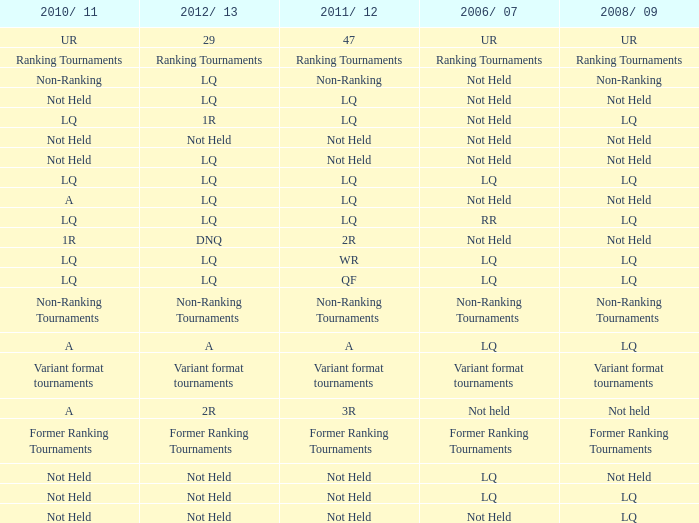Could you parse the entire table? {'header': ['2010/ 11', '2012/ 13', '2011/ 12', '2006/ 07', '2008/ 09'], 'rows': [['UR', '29', '47', 'UR', 'UR'], ['Ranking Tournaments', 'Ranking Tournaments', 'Ranking Tournaments', 'Ranking Tournaments', 'Ranking Tournaments'], ['Non-Ranking', 'LQ', 'Non-Ranking', 'Not Held', 'Non-Ranking'], ['Not Held', 'LQ', 'LQ', 'Not Held', 'Not Held'], ['LQ', '1R', 'LQ', 'Not Held', 'LQ'], ['Not Held', 'Not Held', 'Not Held', 'Not Held', 'Not Held'], ['Not Held', 'LQ', 'Not Held', 'Not Held', 'Not Held'], ['LQ', 'LQ', 'LQ', 'LQ', 'LQ'], ['A', 'LQ', 'LQ', 'Not Held', 'Not Held'], ['LQ', 'LQ', 'LQ', 'RR', 'LQ'], ['1R', 'DNQ', '2R', 'Not Held', 'Not Held'], ['LQ', 'LQ', 'WR', 'LQ', 'LQ'], ['LQ', 'LQ', 'QF', 'LQ', 'LQ'], ['Non-Ranking Tournaments', 'Non-Ranking Tournaments', 'Non-Ranking Tournaments', 'Non-Ranking Tournaments', 'Non-Ranking Tournaments'], ['A', 'A', 'A', 'LQ', 'LQ'], ['Variant format tournaments', 'Variant format tournaments', 'Variant format tournaments', 'Variant format tournaments', 'Variant format tournaments'], ['A', '2R', '3R', 'Not held', 'Not held'], ['Former Ranking Tournaments', 'Former Ranking Tournaments', 'Former Ranking Tournaments', 'Former Ranking Tournaments', 'Former Ranking Tournaments'], ['Not Held', 'Not Held', 'Not Held', 'LQ', 'Not Held'], ['Not Held', 'Not Held', 'Not Held', 'LQ', 'LQ'], ['Not Held', 'Not Held', 'Not Held', 'Not Held', 'LQ']]} What is 2006/07, when 2008/09 is LQ, when 2012/13 is LQ, and when 2011/12 is WR? LQ. 